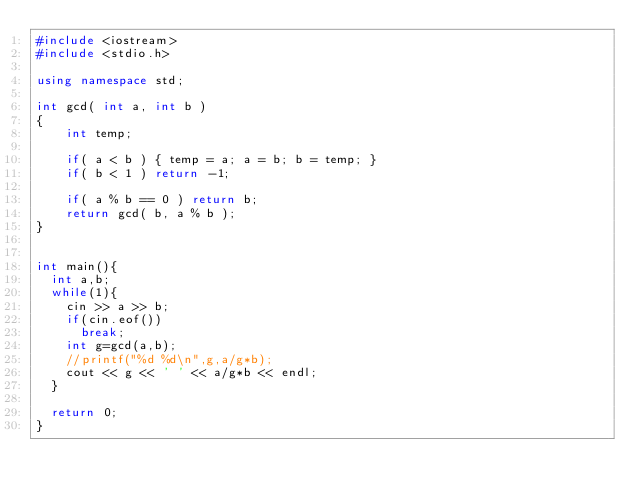<code> <loc_0><loc_0><loc_500><loc_500><_C++_>#include <iostream>
#include <stdio.h>

using namespace std; 

int gcd( int a, int b )
{
    int temp;

    if( a < b ) { temp = a; a = b; b = temp; }
    if( b < 1 ) return -1;

    if( a % b == 0 ) return b;
    return gcd( b, a % b );
}


int main(){
  int a,b;
  while(1){
    cin >> a >> b;
    if(cin.eof())
      break;
    int g=gcd(a,b);
    //printf("%d %d\n",g,a/g*b);
    cout << g << ' ' << a/g*b << endl;
  }

  return 0;
}

</code> 